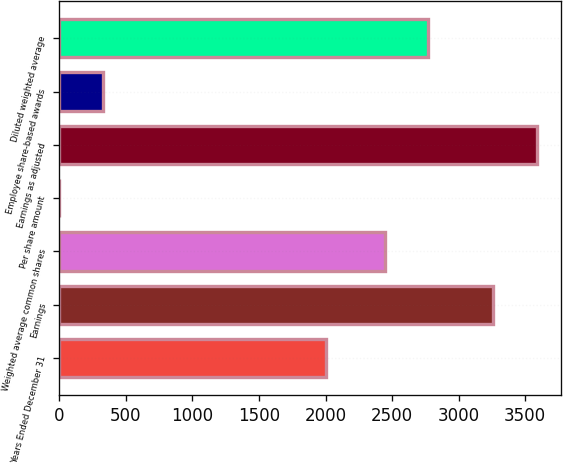<chart> <loc_0><loc_0><loc_500><loc_500><bar_chart><fcel>Years Ended December 31<fcel>Earnings<fcel>Weighted average common shares<fcel>Per share amount<fcel>Earnings as adjusted<fcel>Employee share-based awards<fcel>Diluted weighted average<nl><fcel>2006<fcel>3261<fcel>2446.3<fcel>1.33<fcel>3586.97<fcel>327.3<fcel>2772.27<nl></chart> 